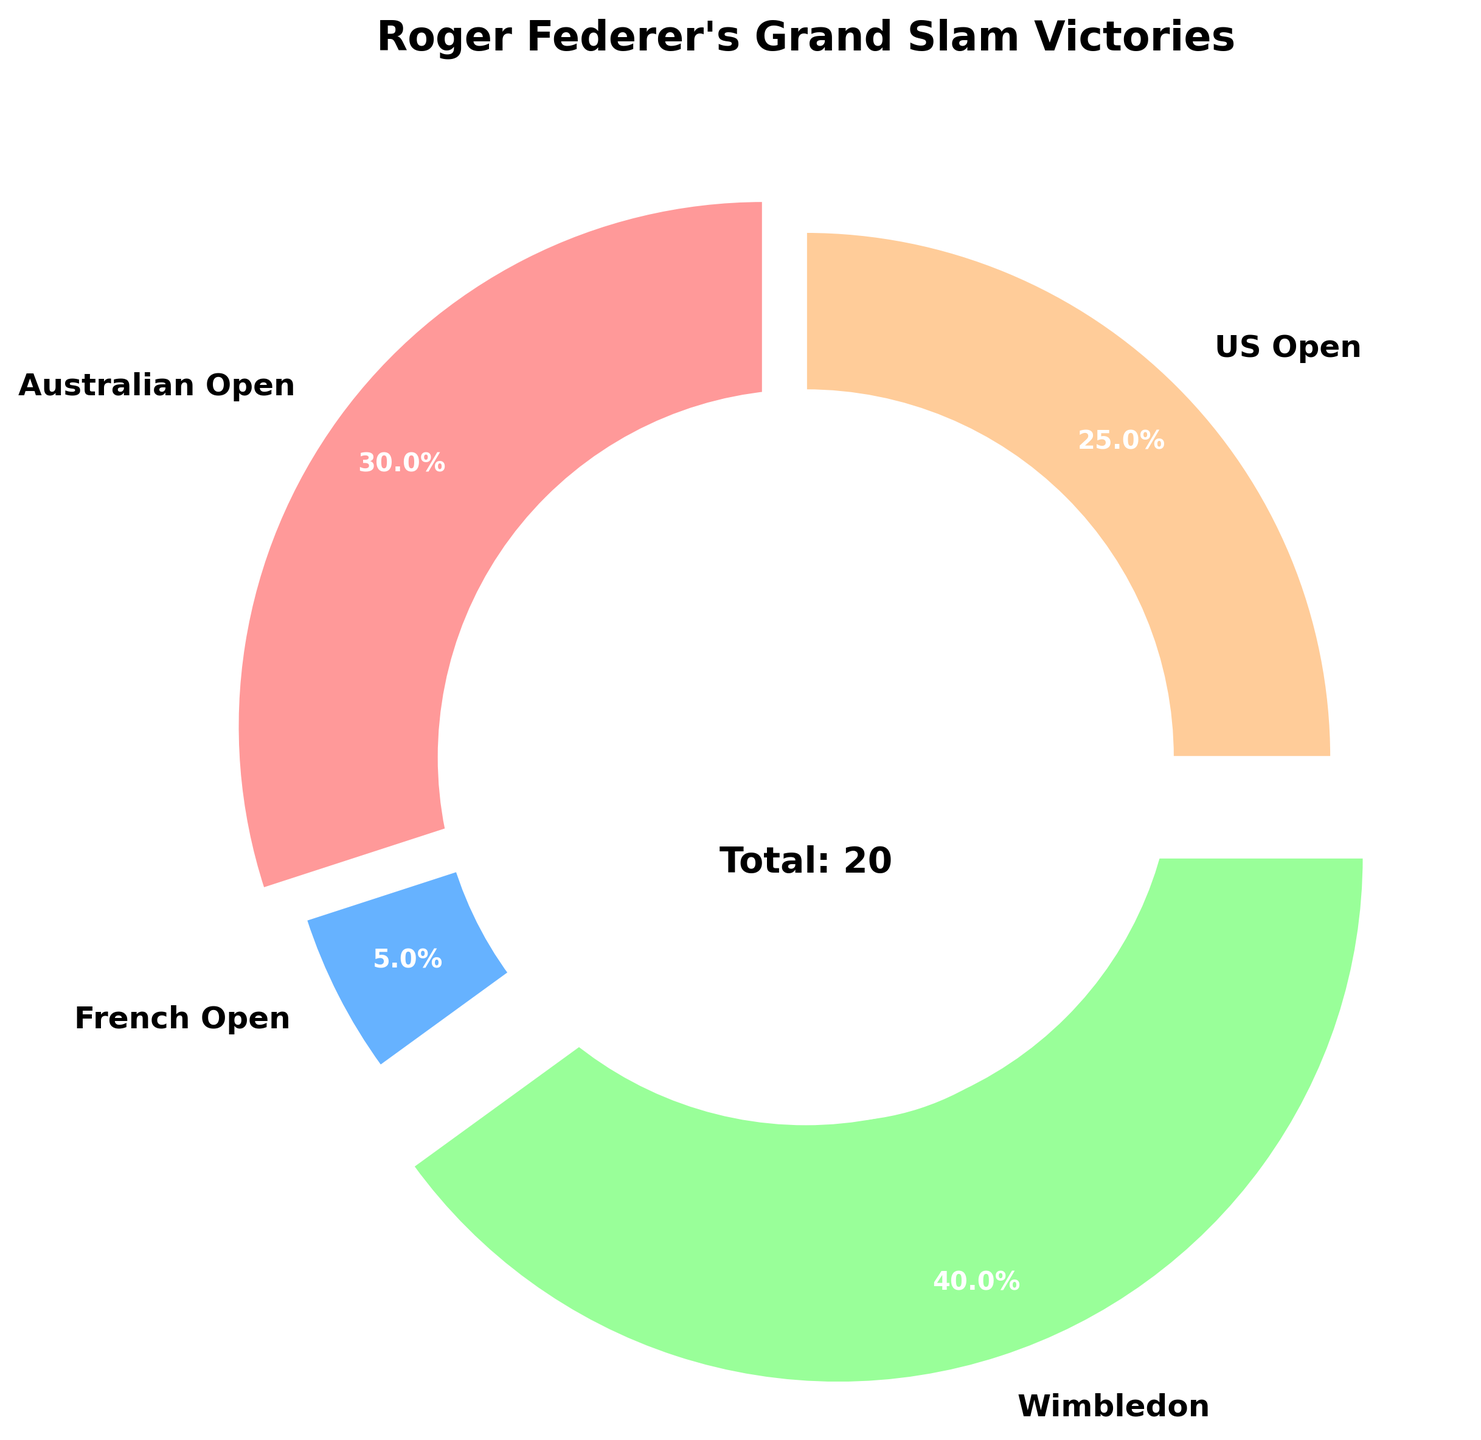What percentage of Roger Federer's Grand Slam titles were won at Wimbledon? The figure shows the titles percentage. Find the wedge labeled "Wimbledon," which has "40.0%" indicated.
Answer: 40.0% Which tournament has the least number of Roger Federer's Grand Slam titles? Visual inspection shows the smallest wedge corresponds to the French Open labeled with 5.0%.
Answer: French Open How many total Grand Slam titles did Roger Federer win at the US Open and Australian Open combined? According to the visual data, Australian Open has 6 titles, and US Open has 5 titles. The combined total is 6 + 5.
Answer: 11 Is the number of Grand Slam titles won by Roger Federer at the Australian Open greater than at the US Open? Comparing the sizes of the wedges and labels directly: Australian Open has 6 titles while US Open has 5 titles.
Answer: Yes What is the approximate difference in percentages between titles won at Wimbledon and at the US Open? Wimbledon wedge is labeled 40.0%, and US Open is 25.0%. The difference is 40.0% - 25.0%.
Answer: 15.0% What fraction of Roger Federer's Grand Slam titles is composed of Wimbledon titles? Federer won 8 Wimbledon titles out of a total of 20 Grand Slam titles. The fraction is 8/20.
Answer: 2/5 Which Grand Slam tournament has Roger Federer won the second most titles in? By visual inspection, the second-largest wedge is for the Australian Open after Wimbledon.
Answer: Australian Open What's the total number of Roger Federer's Grand Slam titles depicted in the figure? The figure includes an annotation 'Total: 20' in the center of the pie chart.
Answer: 20 What percentage do Roger Federer's titles at the French Open contribute to his total Grand Slam wins? The figure shows French Open titles forms 5.0% of the total Grand Slam titles.
Answer: 5.0% If Roger Federer had won 3 more titles at Wimbledon, what would be the new percentage of his Wimbledon wins out of his total Grand Slam victories? With 3 additional Wimbledon titles, the total titles become 8 + 3 = 11 for Wimbledon and total Grand Slam wins become 20 + 3 = 23. The new percentage is (11/23) * 100.
Answer: 47.83% 